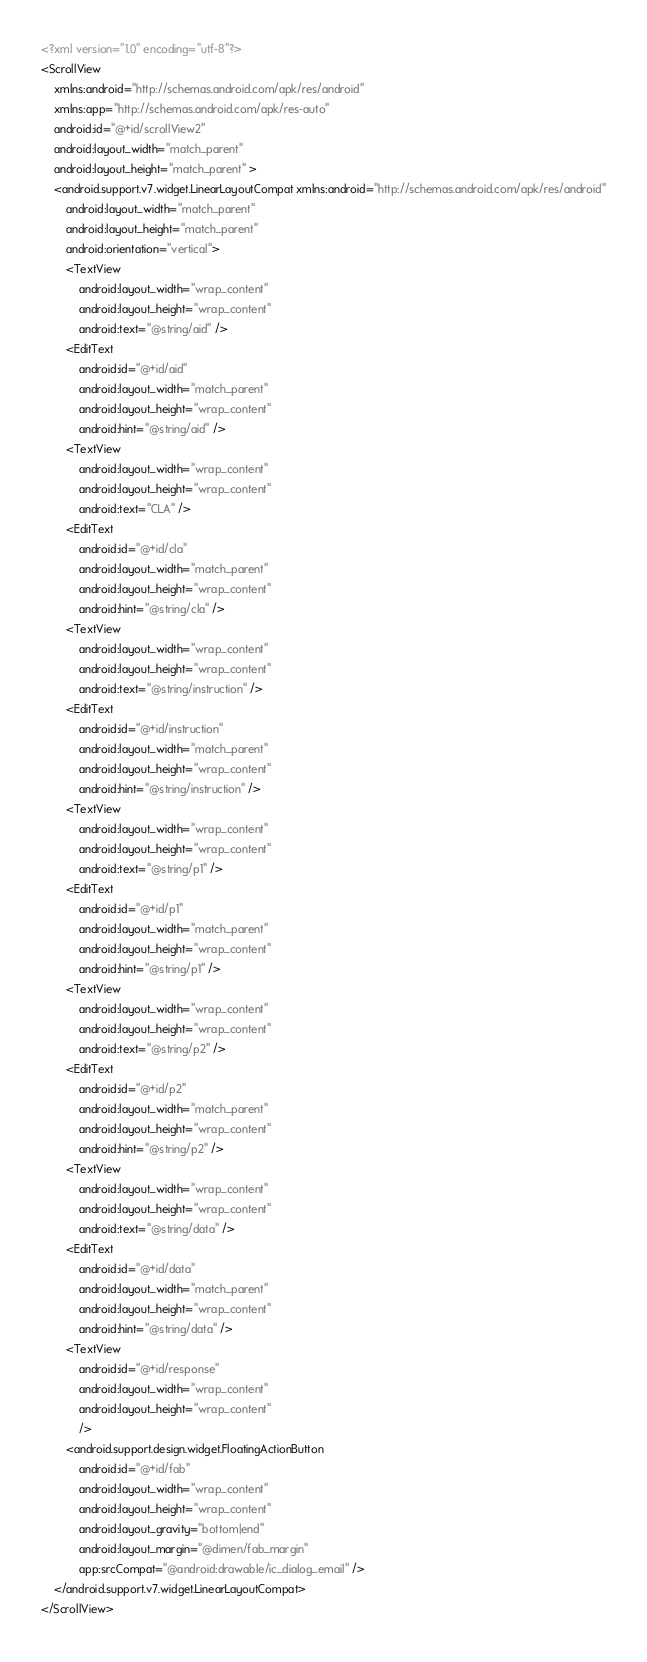<code> <loc_0><loc_0><loc_500><loc_500><_XML_><?xml version="1.0" encoding="utf-8"?>
<ScrollView
    xmlns:android="http://schemas.android.com/apk/res/android"
    xmlns:app="http://schemas.android.com/apk/res-auto"
    android:id="@+id/scrollView2"
    android:layout_width="match_parent"
    android:layout_height="match_parent" >
    <android.support.v7.widget.LinearLayoutCompat xmlns:android="http://schemas.android.com/apk/res/android"
        android:layout_width="match_parent"
        android:layout_height="match_parent"
        android:orientation="vertical">
        <TextView
            android:layout_width="wrap_content"
            android:layout_height="wrap_content"
            android:text="@string/aid" />
        <EditText
            android:id="@+id/aid"
            android:layout_width="match_parent"
            android:layout_height="wrap_content"
            android:hint="@string/aid" />
        <TextView
            android:layout_width="wrap_content"
            android:layout_height="wrap_content"
            android:text="CLA" />
        <EditText
            android:id="@+id/cla"
            android:layout_width="match_parent"
            android:layout_height="wrap_content"
            android:hint="@string/cla" />
        <TextView
            android:layout_width="wrap_content"
            android:layout_height="wrap_content"
            android:text="@string/instruction" />
        <EditText
            android:id="@+id/instruction"
            android:layout_width="match_parent"
            android:layout_height="wrap_content"
            android:hint="@string/instruction" />
        <TextView
            android:layout_width="wrap_content"
            android:layout_height="wrap_content"
            android:text="@string/p1" />
        <EditText
            android:id="@+id/p1"
            android:layout_width="match_parent"
            android:layout_height="wrap_content"
            android:hint="@string/p1" />
        <TextView
            android:layout_width="wrap_content"
            android:layout_height="wrap_content"
            android:text="@string/p2" />
        <EditText
            android:id="@+id/p2"
            android:layout_width="match_parent"
            android:layout_height="wrap_content"
            android:hint="@string/p2" />
        <TextView
            android:layout_width="wrap_content"
            android:layout_height="wrap_content"
            android:text="@string/data" />
        <EditText
            android:id="@+id/data"
            android:layout_width="match_parent"
            android:layout_height="wrap_content"
            android:hint="@string/data" />
        <TextView
            android:id="@+id/response"
            android:layout_width="wrap_content"
            android:layout_height="wrap_content"
            />
        <android.support.design.widget.FloatingActionButton
            android:id="@+id/fab"
            android:layout_width="wrap_content"
            android:layout_height="wrap_content"
            android:layout_gravity="bottom|end"
            android:layout_margin="@dimen/fab_margin"
            app:srcCompat="@android:drawable/ic_dialog_email" />
    </android.support.v7.widget.LinearLayoutCompat>
</ScrollView>
</code> 